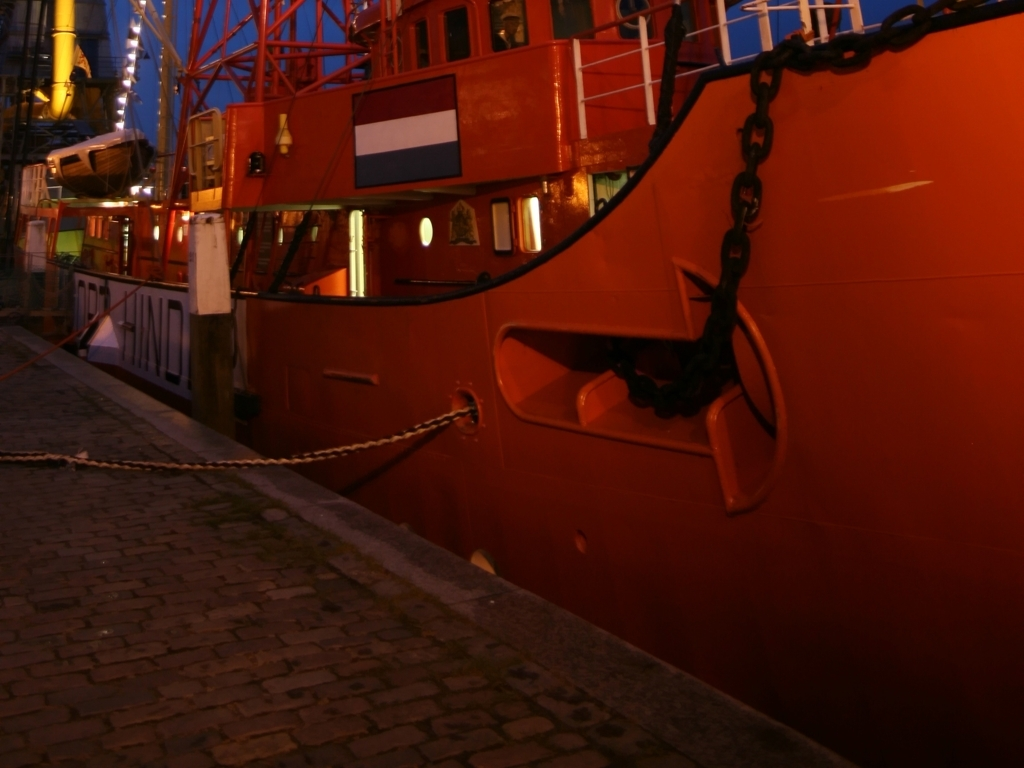What details can you describe about the ship in the image? The ship appears to be a medium-sized, possibly industrial or service-oriented vessel, painted in vivid orange and featuring details like lifeboats, guard rails, and visible deck equipment. There's a prominent anchor at the bow, and the hull is marked with water-level indicators. The scene looks like a commercial harbor or dockyard. If you were to imagine the history or story of this ship, what would it be? I'd imagine this ship has a history of service, possibly as part of a coastal maintenance fleet or as a support vessel for larger ships. It likely has seen countless harbors and been through a multitude of operations, possibly even rescue missions, as indicated by the lifesaving equipment onboard. Its robust build and practical design speak to a functional life on the water. 